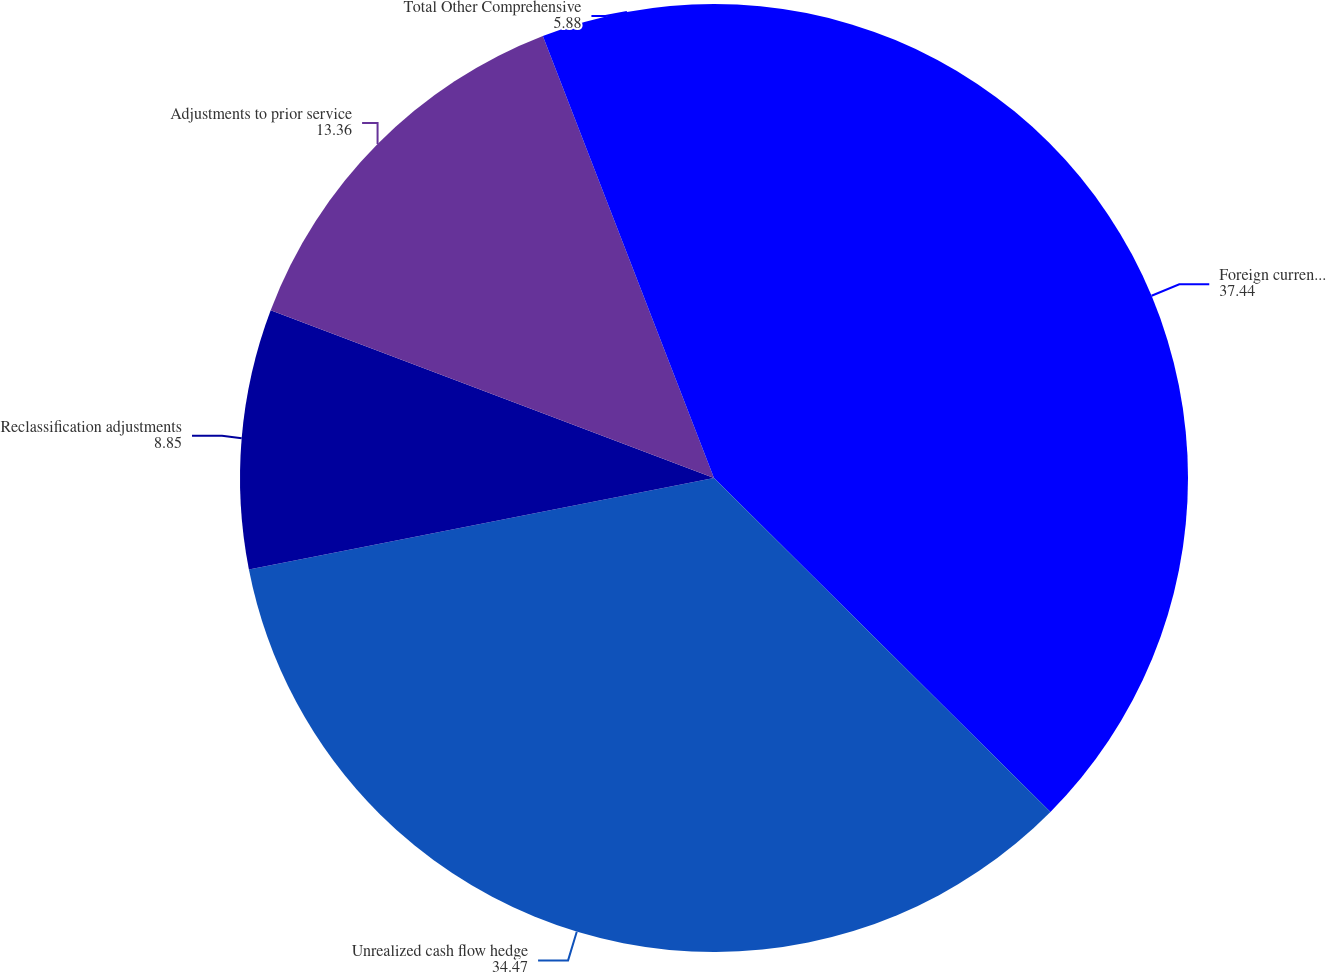Convert chart. <chart><loc_0><loc_0><loc_500><loc_500><pie_chart><fcel>Foreign currency cumulative<fcel>Unrealized cash flow hedge<fcel>Reclassification adjustments<fcel>Adjustments to prior service<fcel>Total Other Comprehensive<nl><fcel>37.44%<fcel>34.47%<fcel>8.85%<fcel>13.36%<fcel>5.88%<nl></chart> 